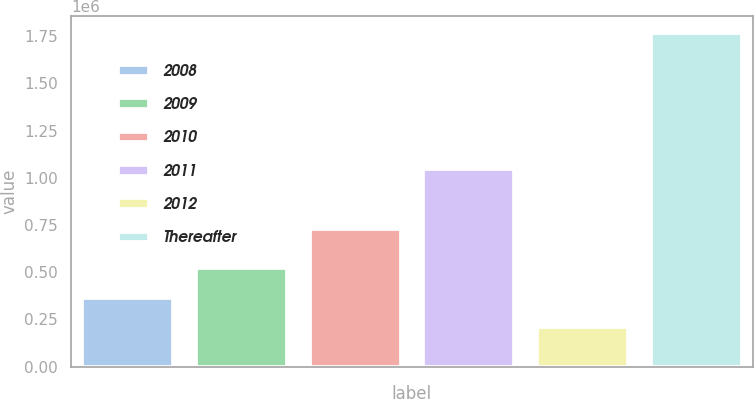Convert chart to OTSL. <chart><loc_0><loc_0><loc_500><loc_500><bar_chart><fcel>2008<fcel>2009<fcel>2010<fcel>2011<fcel>2012<fcel>Thereafter<nl><fcel>365017<fcel>520801<fcel>728253<fcel>1.04639e+06<fcel>209233<fcel>1.76707e+06<nl></chart> 